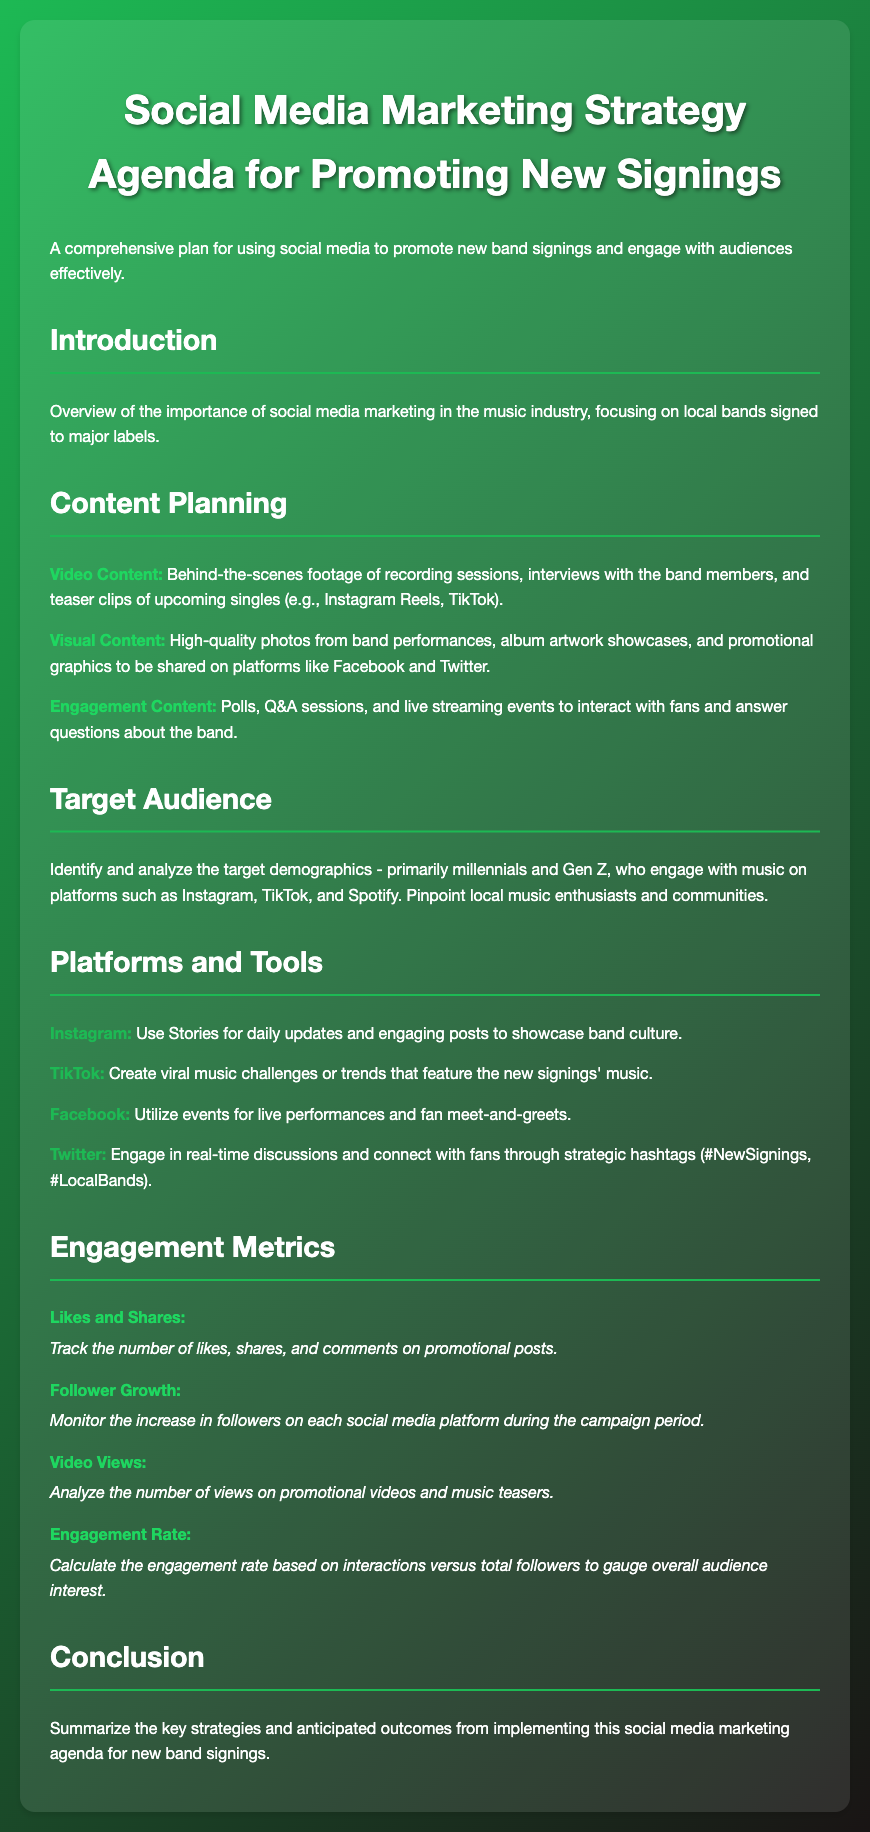what is the title of the agenda? The title of the agenda is stated at the beginning of the document, which outlines its focus on promoting new band signings.
Answer: Social Media Marketing Strategy Agenda for Promoting New Signings what type of content is mentioned for engagement? The document outlines various types of content, specifically stating what engages the audience effectively.
Answer: Polls, Q&A sessions, and live streaming events who is the primary target demographic? The document identifies the main target audience demographic for the social media strategy.
Answer: millennials and Gen Z which platform is recommended for music challenges? The agenda specifies a platform suitable for creating viral trends or challenges.
Answer: TikTok what metric is used to gauge audience interest? The document describes how to calculate audience interest based on interactions and followers.
Answer: Engagement Rate how many content types are listed under Content Planning? The document lists different types of content in the Content Planning section and specifies the total count.
Answer: Three what is mentioned as a key strategy for Instagram? The document suggests specific strategies for engaging content on Instagram.
Answer: Use Stories for daily updates what is the color of the header text in the document? The visual design of the document uses a specific color theme for header text.
Answer: White what metric tracks the increase in followers? The document identifies a specific engagement metric that relates to follower count growth.
Answer: Follower Growth 